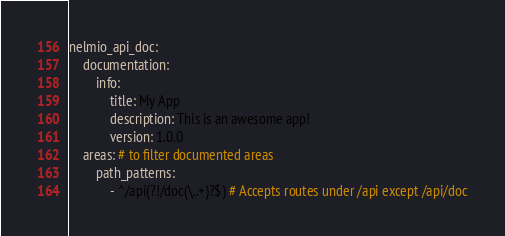Convert code to text. <code><loc_0><loc_0><loc_500><loc_500><_YAML_>nelmio_api_doc:
    documentation:
        info:
            title: My App
            description: This is an awesome app!
            version: 1.0.0
    areas: # to filter documented areas
        path_patterns:
            - ^/api(?!/doc(\..+)?$) # Accepts routes under /api except /api/doc
</code> 